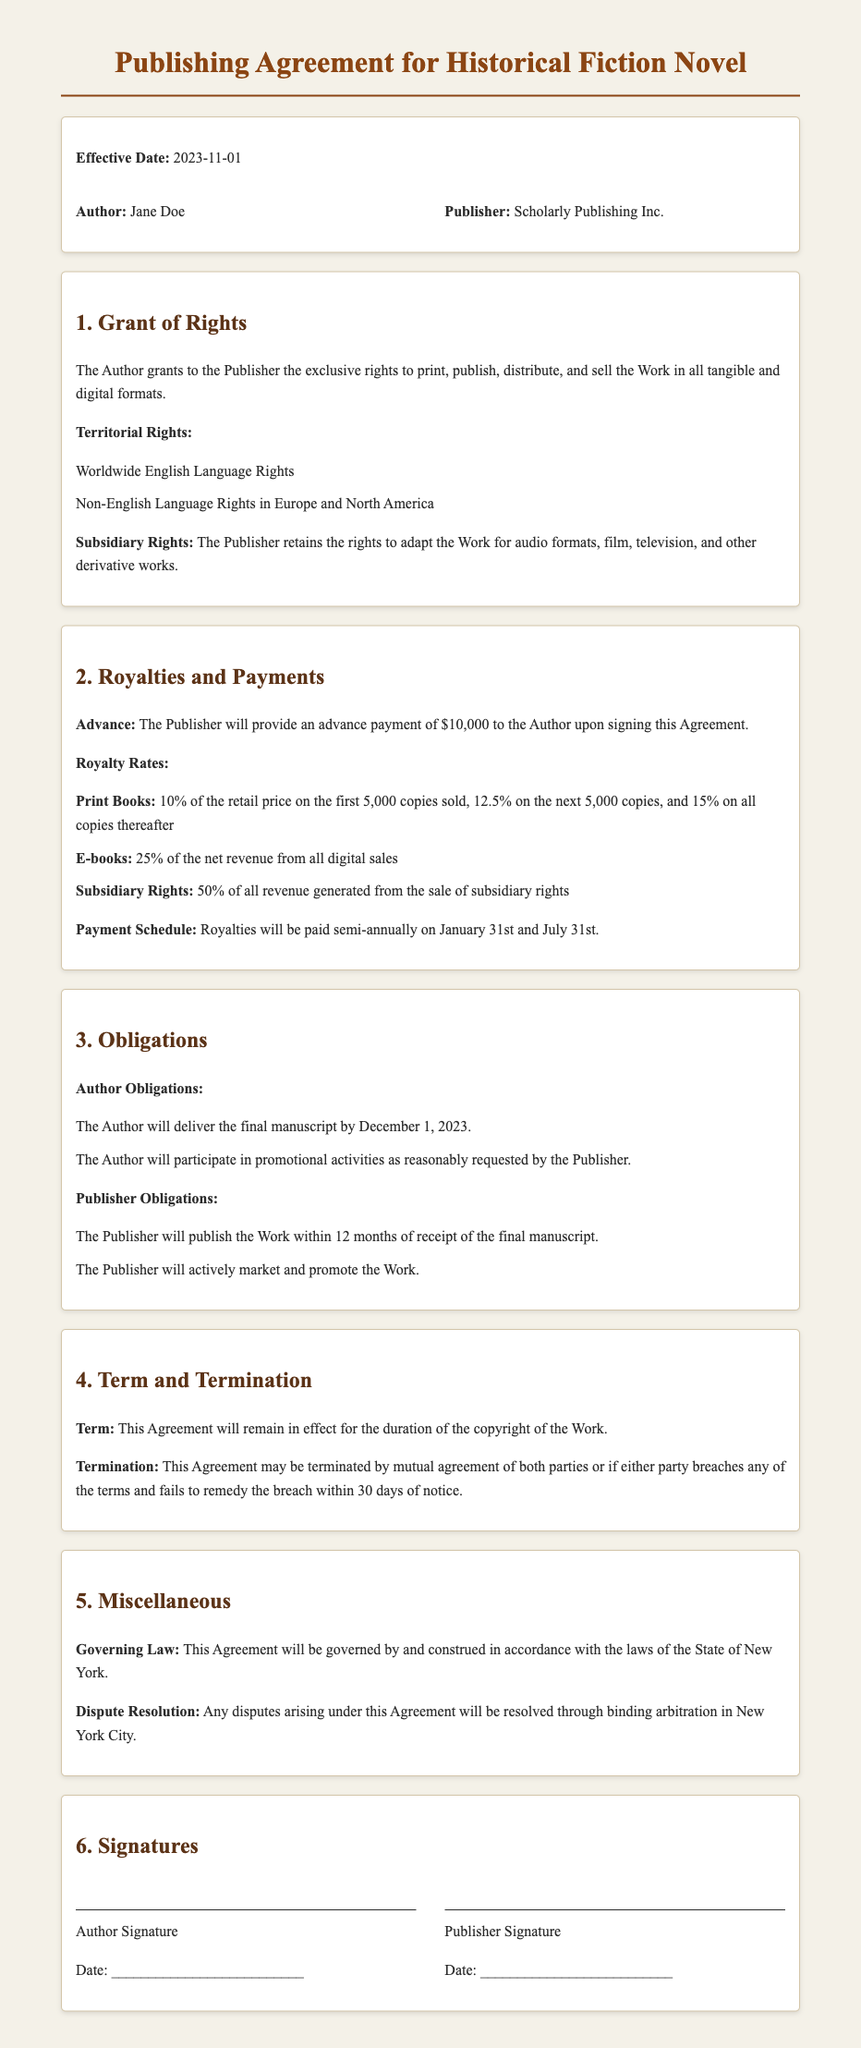What is the effective date of the agreement? The effective date is stated in the document as the commencement of the agreement.
Answer: 2023-11-01 Who is the author? The author is identified as one of the primary parties in the agreement.
Answer: Jane Doe What is the advance payment amount? The advance payment amount is specified under the royalties and payments section of the document.
Answer: $10,000 What are the royalty rates for print books? The royalty rates for print books are outlined in the royalties and payments section with specific percentages.
Answer: 10%, 12.5%, 15% How long will the agreement remain in effect? The duration of the agreement is mentioned in the term section of the document.
Answer: Duration of the copyright of the Work What is one of the author obligations? The author obligations section lists requirements that the author must fulfill.
Answer: Deliver the final manuscript by December 1, 2023 What rights does the publisher retain for adaptations? The rights retained by the publisher for adaptations are specified in the grant of rights section.
Answer: Subsidiary Rights In which city will disputes be resolved? The dispute resolution section specifies the location for resolving disputes outlined in the agreement.
Answer: New York City 